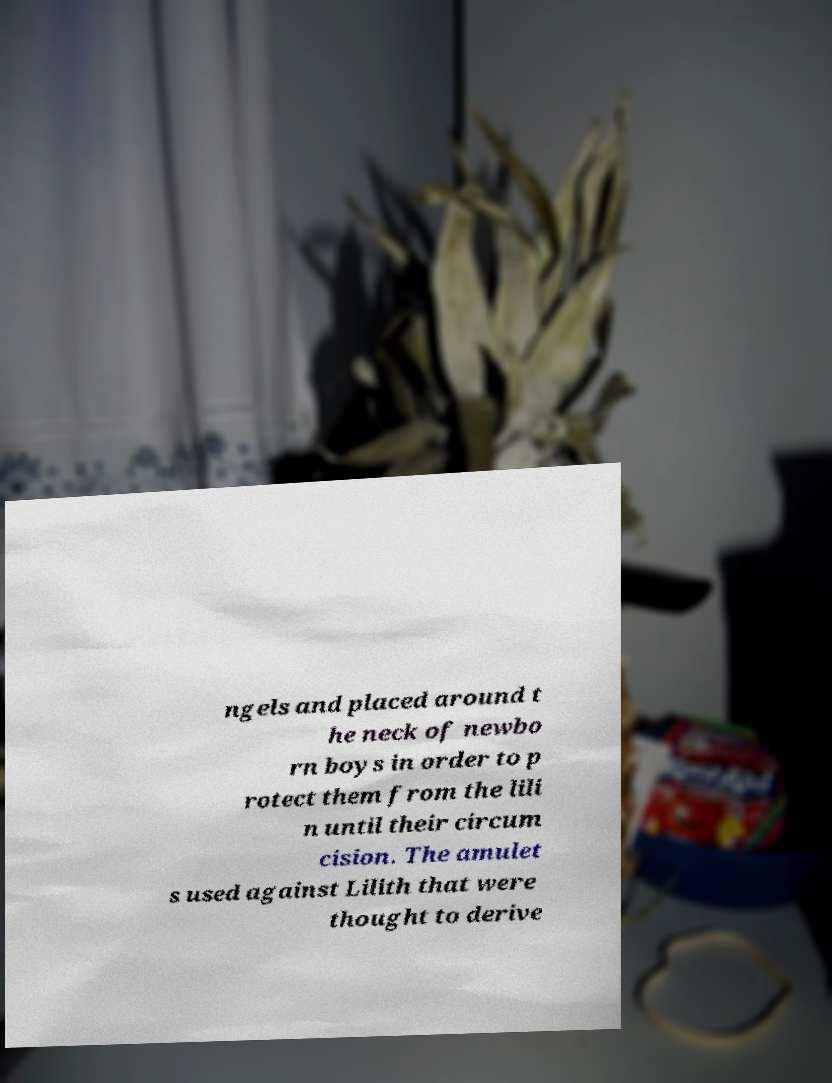There's text embedded in this image that I need extracted. Can you transcribe it verbatim? ngels and placed around t he neck of newbo rn boys in order to p rotect them from the lili n until their circum cision. The amulet s used against Lilith that were thought to derive 